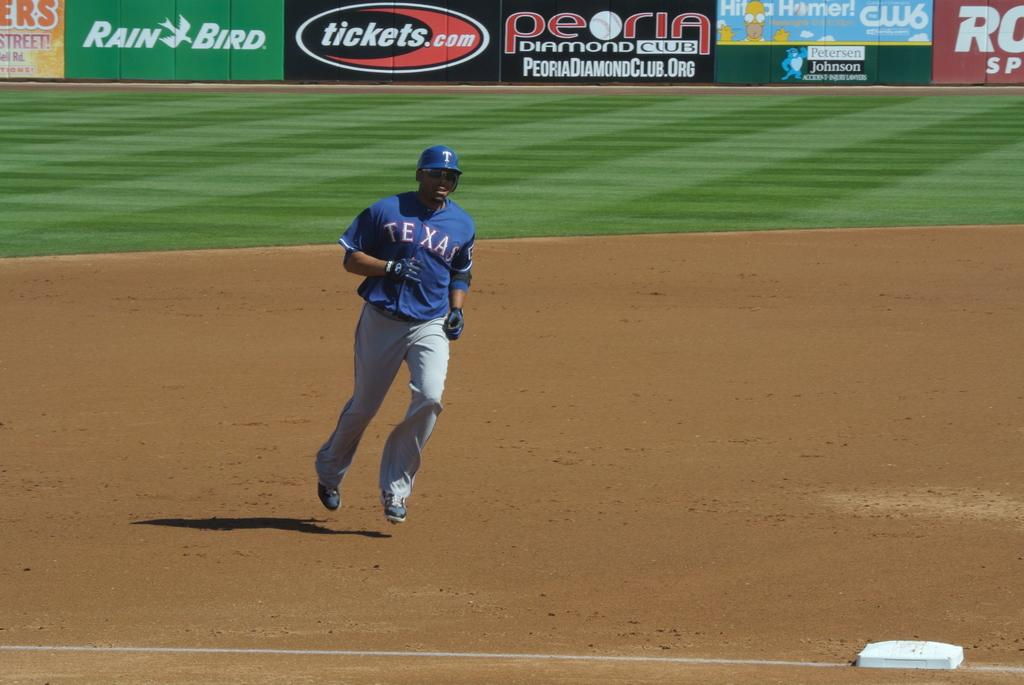<image>
Render a clear and concise summary of the photo. A sportsman with the word Texas on a blue shirt. 